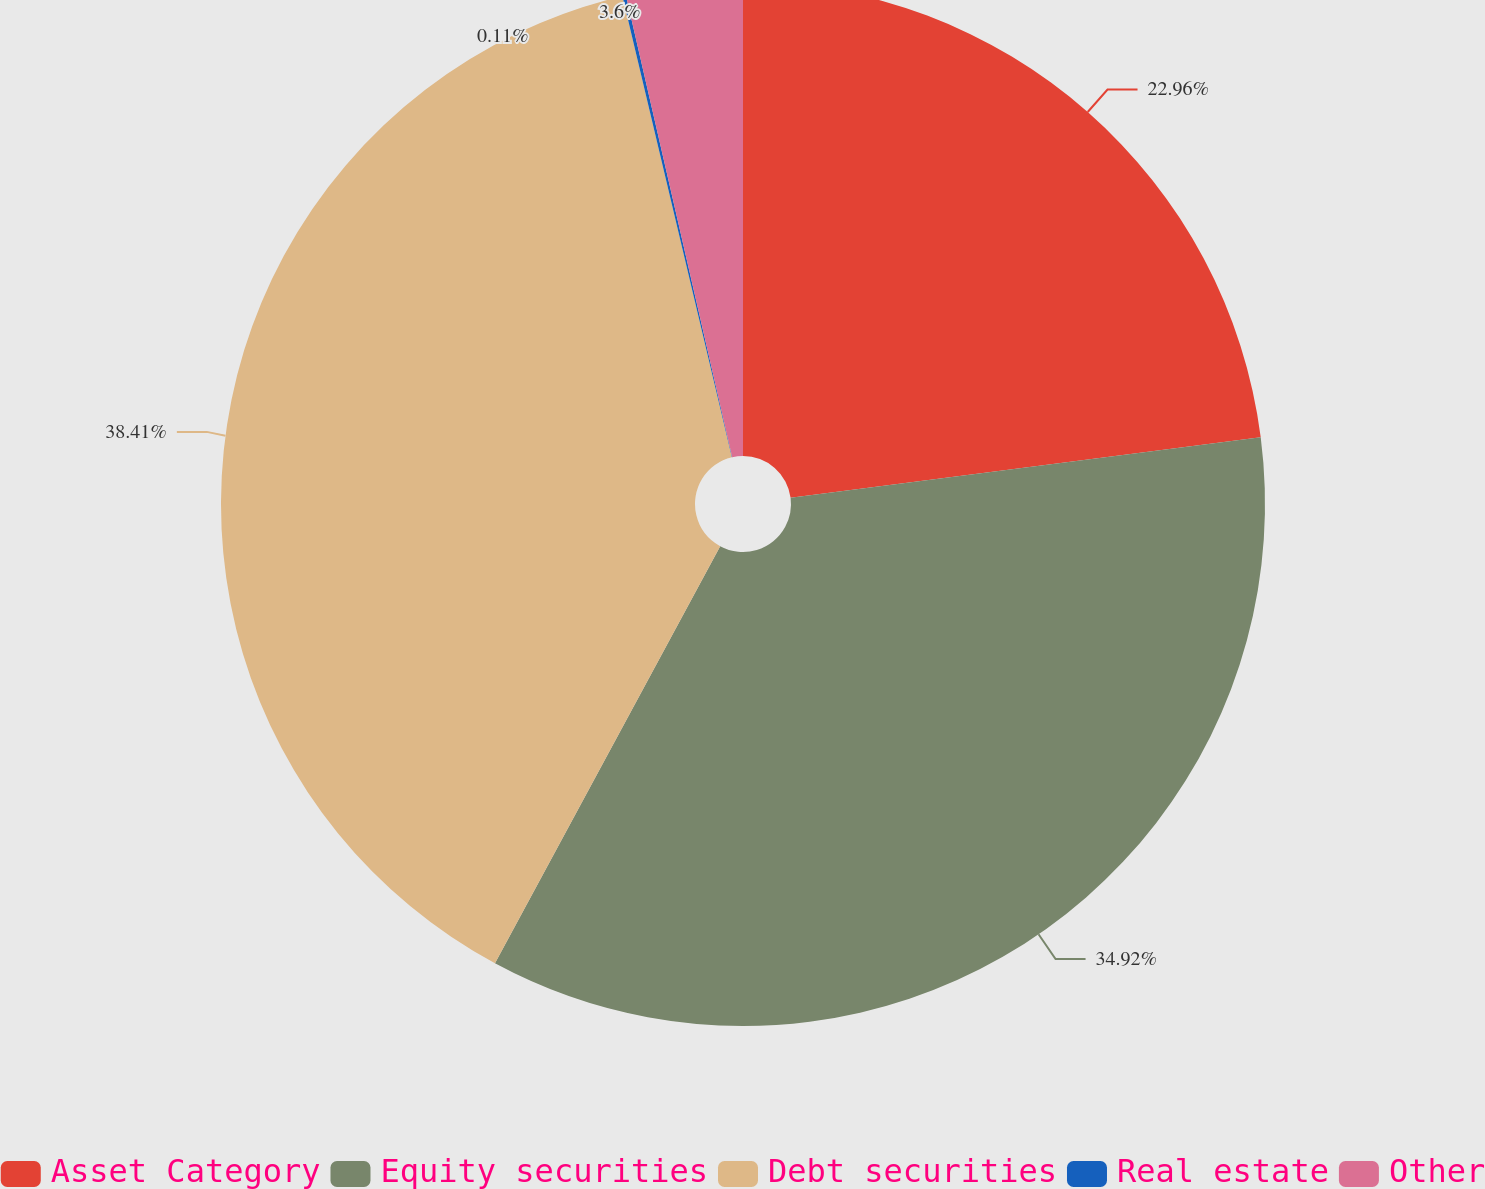<chart> <loc_0><loc_0><loc_500><loc_500><pie_chart><fcel>Asset Category<fcel>Equity securities<fcel>Debt securities<fcel>Real estate<fcel>Other<nl><fcel>22.96%<fcel>34.92%<fcel>38.41%<fcel>0.11%<fcel>3.6%<nl></chart> 